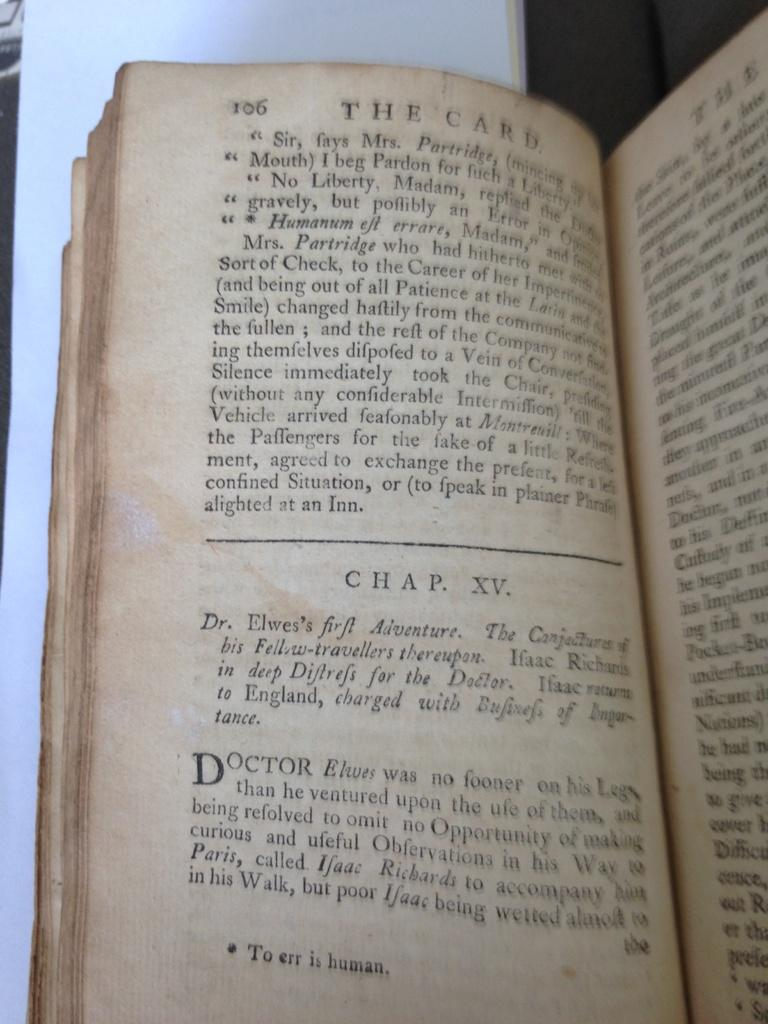<image>
Render a clear and concise summary of the photo. Page 106 of an open book says to err is human at the very bottom. 